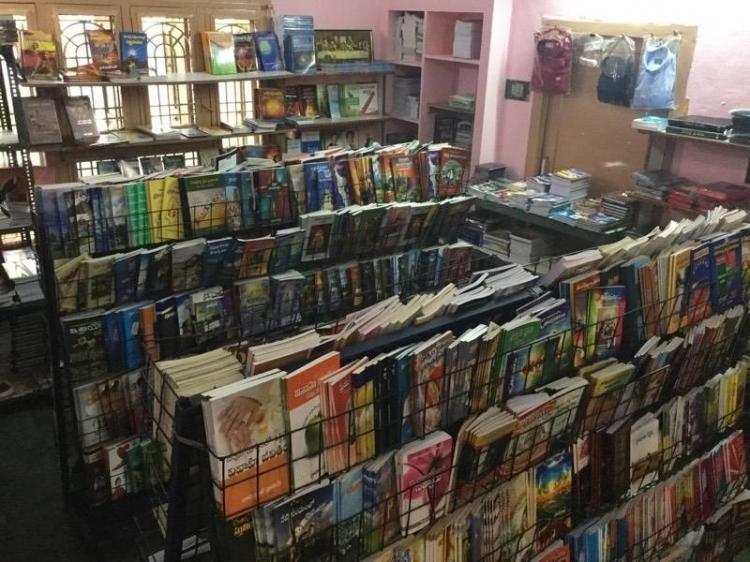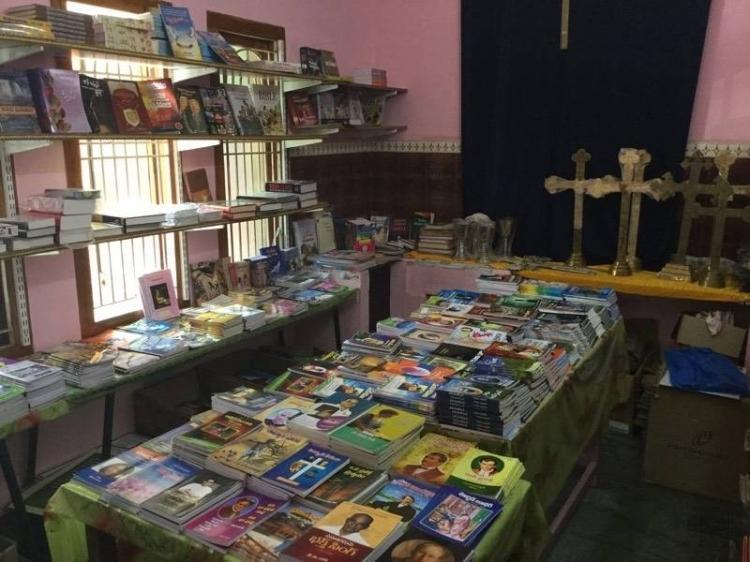The first image is the image on the left, the second image is the image on the right. For the images shown, is this caption "There are two bookstores, with bright light visible through the windows of at least one." true? Answer yes or no. Yes. The first image is the image on the left, the second image is the image on the right. Evaluate the accuracy of this statement regarding the images: "At least one image shows a bookshop that uses royal blue in its color scheme.". Is it true? Answer yes or no. No. 